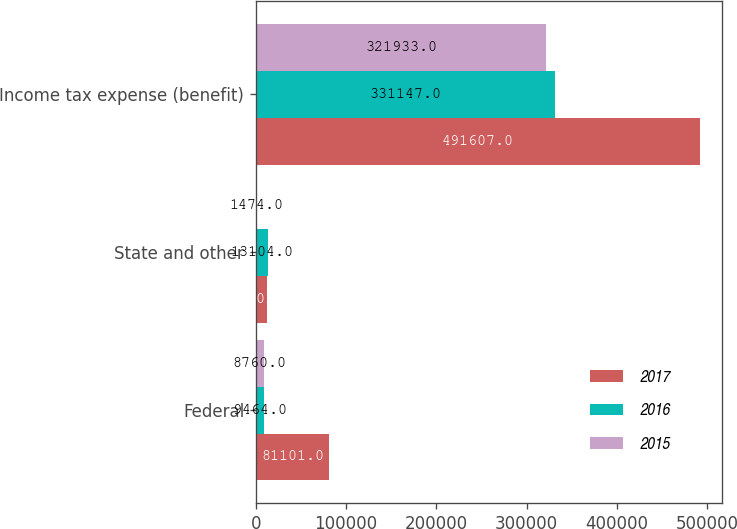<chart> <loc_0><loc_0><loc_500><loc_500><stacked_bar_chart><ecel><fcel>Federal<fcel>State and other<fcel>Income tax expense (benefit)<nl><fcel>2017<fcel>81101<fcel>11801<fcel>491607<nl><fcel>2016<fcel>9464<fcel>13104<fcel>331147<nl><fcel>2015<fcel>8760<fcel>1474<fcel>321933<nl></chart> 